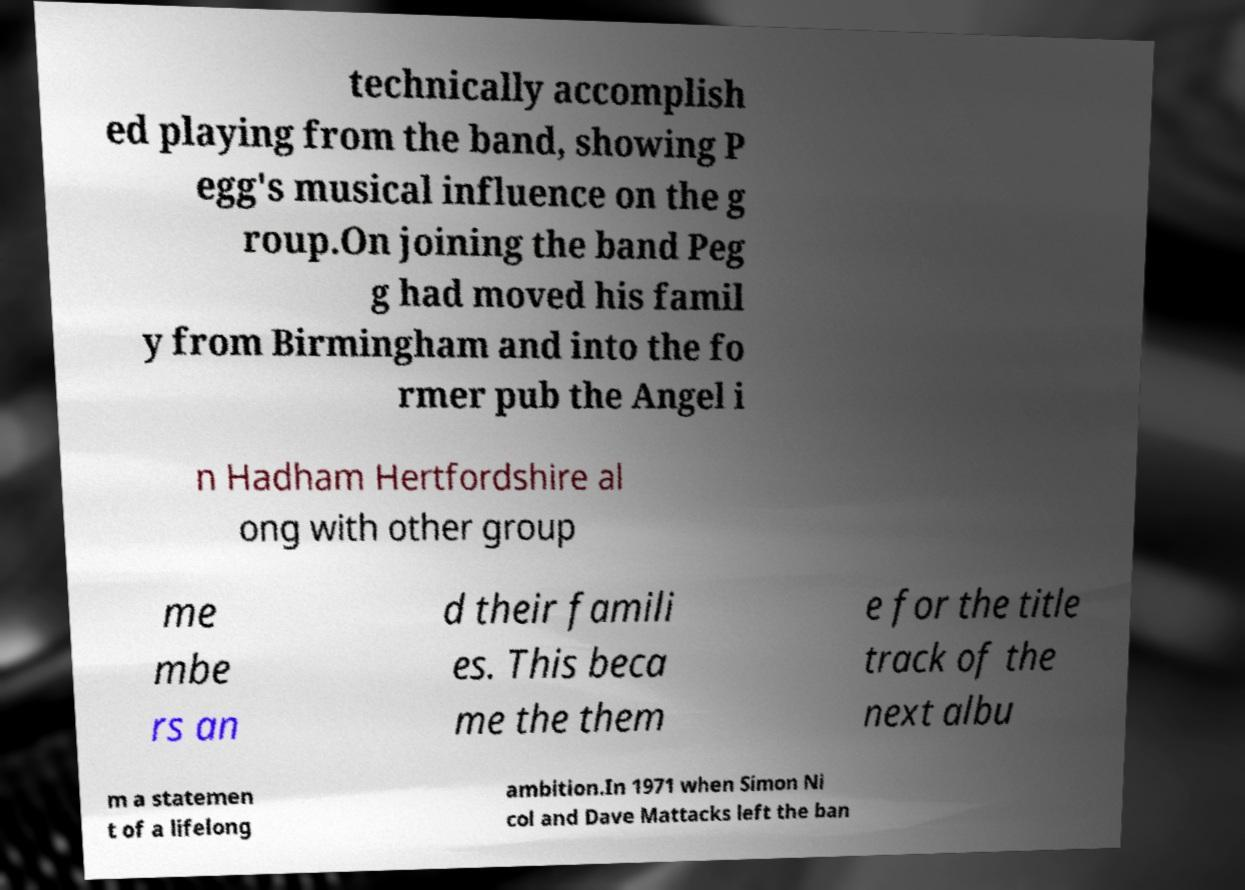Can you read and provide the text displayed in the image?This photo seems to have some interesting text. Can you extract and type it out for me? technically accomplish ed playing from the band, showing P egg's musical influence on the g roup.On joining the band Peg g had moved his famil y from Birmingham and into the fo rmer pub the Angel i n Hadham Hertfordshire al ong with other group me mbe rs an d their famili es. This beca me the them e for the title track of the next albu m a statemen t of a lifelong ambition.In 1971 when Simon Ni col and Dave Mattacks left the ban 